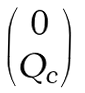Convert formula to latex. <formula><loc_0><loc_0><loc_500><loc_500>\begin{pmatrix} 0 \\ Q _ { c } \end{pmatrix}</formula> 